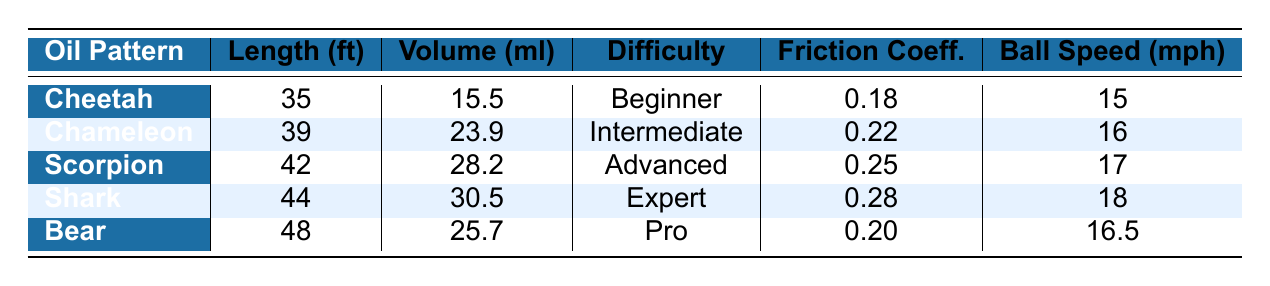What is the oil length of the Cheetah pattern? The Cheetah pattern is listed in the table, and its corresponding oil length is provided as 35 feet.
Answer: 35 feet Which oil pattern has the highest volume? By comparing the volume values in the table, the Shark pattern has the highest oil volume of 30.5 ml.
Answer: Shark What is the recommended ball speed for the Chameleon pattern? The table specifies that the recommended ball speed for the Chameleon pattern is 16 mph.
Answer: 16 mph Is the oil volume for the Bear pattern greater than 25 ml? The Bear pattern's oil volume in the table is 25.7 ml, which is indeed greater than 25 ml.
Answer: Yes What is the average oil length of all patterns? The oil lengths for the patterns are 35, 39, 42, 44, and 48 feet. Adding these values gives 208 feet, and dividing by 5 (the number of patterns) results in an average of 41.6 feet.
Answer: 41.6 feet Which oil pattern is the most challenging based on difficulty? Looking at the difficulty levels, the most challenging oil pattern listed is the Shark pattern, categorized as "Expert."
Answer: Shark What is the total oil volume for all the patterns? The volumes of the patterns are 15.5, 23.9, 28.2, 30.5, and 25.7 ml. Summing these values gives 124.8 ml.
Answer: 124.8 ml What is the friction coefficient of the Scorpion pattern? The friction coefficient for the Scorpion pattern is provided in the table as 0.25.
Answer: 0.25 If you wanted to bowl on a less difficult pattern with minimal oil volume, which pattern would that be? The Cheetah pattern is marked as "Beginner" for difficulty and has the lowest oil volume of 15.5 ml. Therefore, it's the most suitable option.
Answer: Cheetah For which oil pattern is the recommended axis rotation the highest? The table indicates the recommended axis rotation for the Shark pattern is 75 degrees, which is the highest among all patterns.
Answer: Shark 